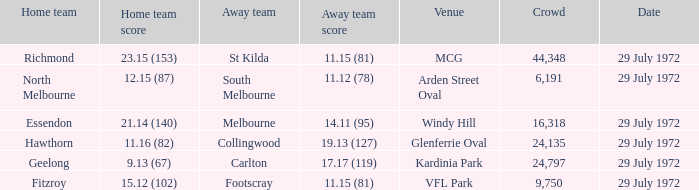What was the greatest gathering size at arden street oval? 6191.0. 